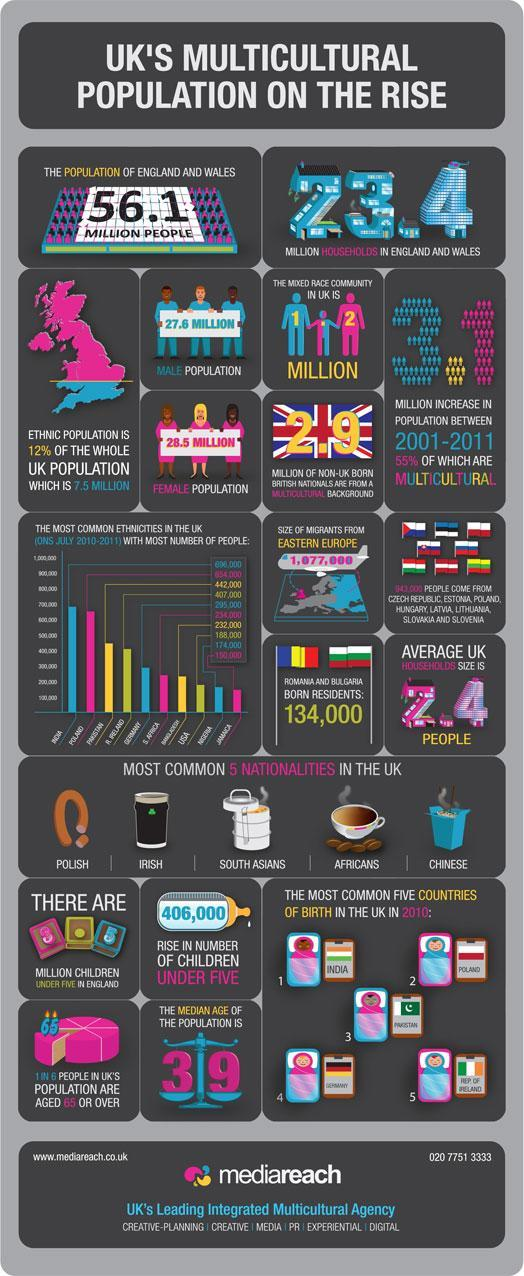What is the rise in number of children under five in UK?
Answer the question with a short phrase. 406,000 What is the population of mixed race community in UK? 1.2 MILLION What is an average UK household size? 2-4 people How many million children are under five in England? 3.5 What is the median age of the UK population? 39 How many non-UK-born British nationals are from a multicultural background? 2.9 Million What is the total female population in UK? 28.5 MILLION How many million households are in England & Wales? 23.4 What is the total male population in UK? 27.6 MILLION 